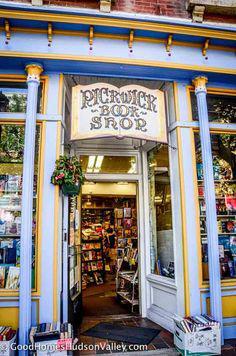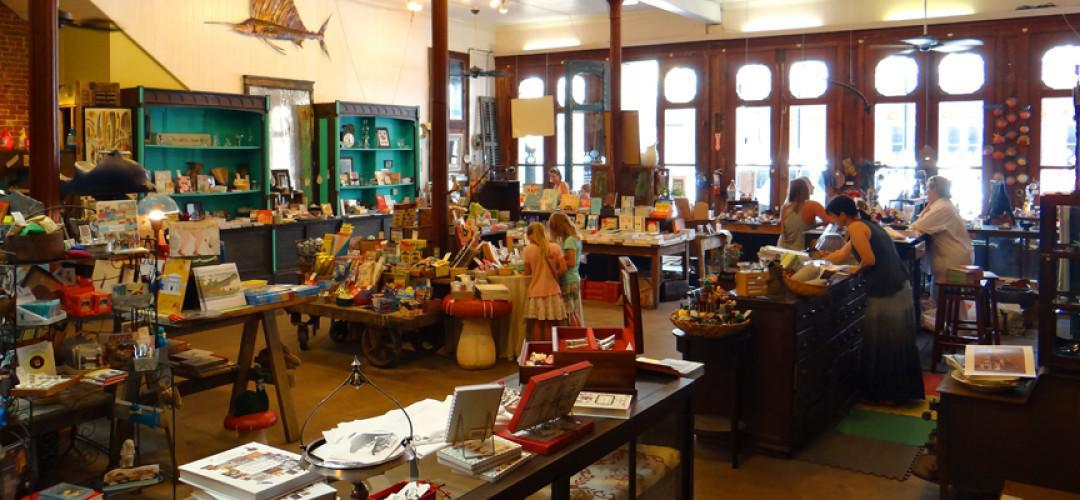The first image is the image on the left, the second image is the image on the right. Analyze the images presented: Is the assertion "One storefront has light stone bordering around wood that is painted navy blue." valid? Answer yes or no. No. The first image is the image on the left, the second image is the image on the right. Assess this claim about the two images: "There are at least two cardboard boxes of books on the pavement outside the book shop.". Correct or not? Answer yes or no. Yes. 